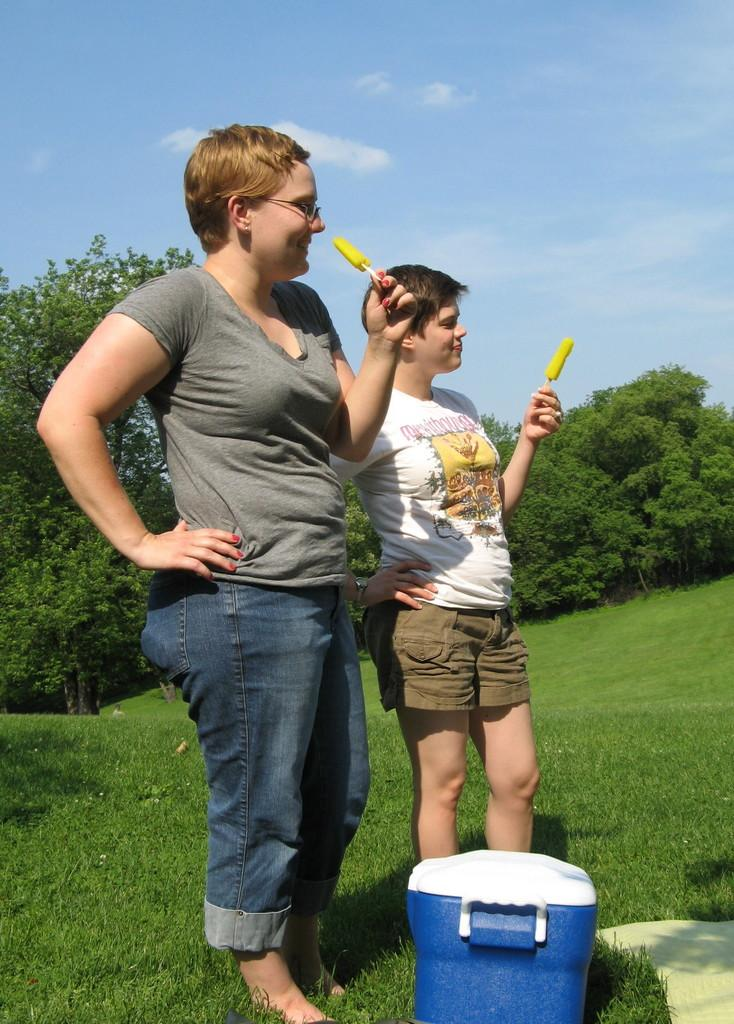How many women are in the image? There are two women in the image. What are the women holding in the image? The women are holding food items. Where are the women standing in the image? The women are standing on the grass. What is present on the grass besides the women? There is an esky on the grass. What can be seen in the background of the image? Trees and the sky are visible in the background. What type of power is being generated by the cabbage in the image? There is no cabbage present in the image, and therefore no power generation can be observed. 